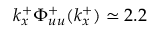<formula> <loc_0><loc_0><loc_500><loc_500>k _ { x } ^ { + } \Phi _ { u u } ^ { + } ( k _ { x } ^ { + } ) \simeq 2 . 2</formula> 